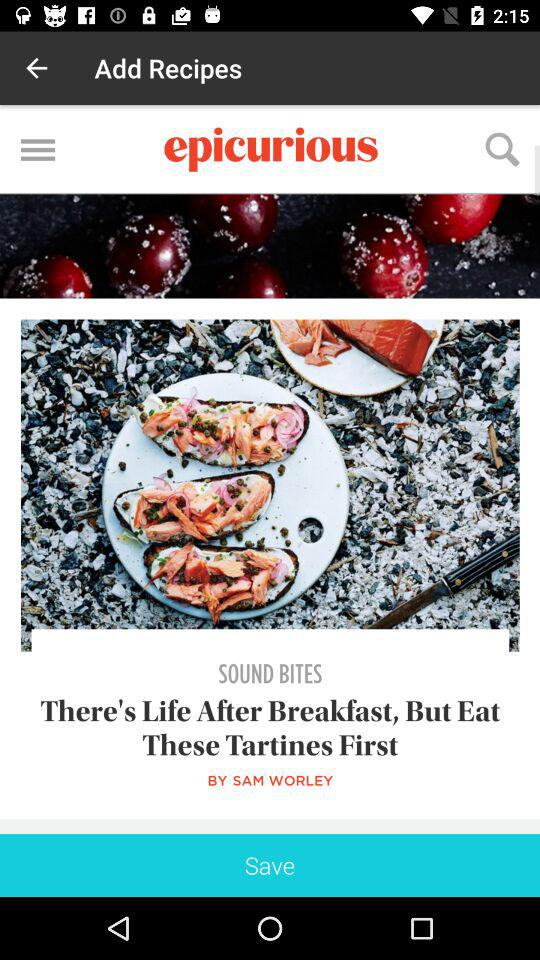What is the title of the article written by Sam Worley? The title of the article is "There's Life After Breakfast, But Eat These Tartines First". 